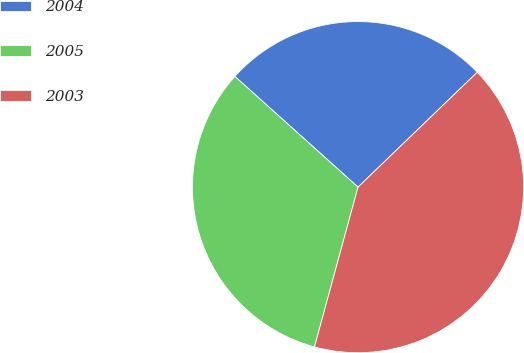<chart> <loc_0><loc_0><loc_500><loc_500><pie_chart><fcel>2004<fcel>2005<fcel>2003<nl><fcel>26.14%<fcel>32.42%<fcel>41.44%<nl></chart> 